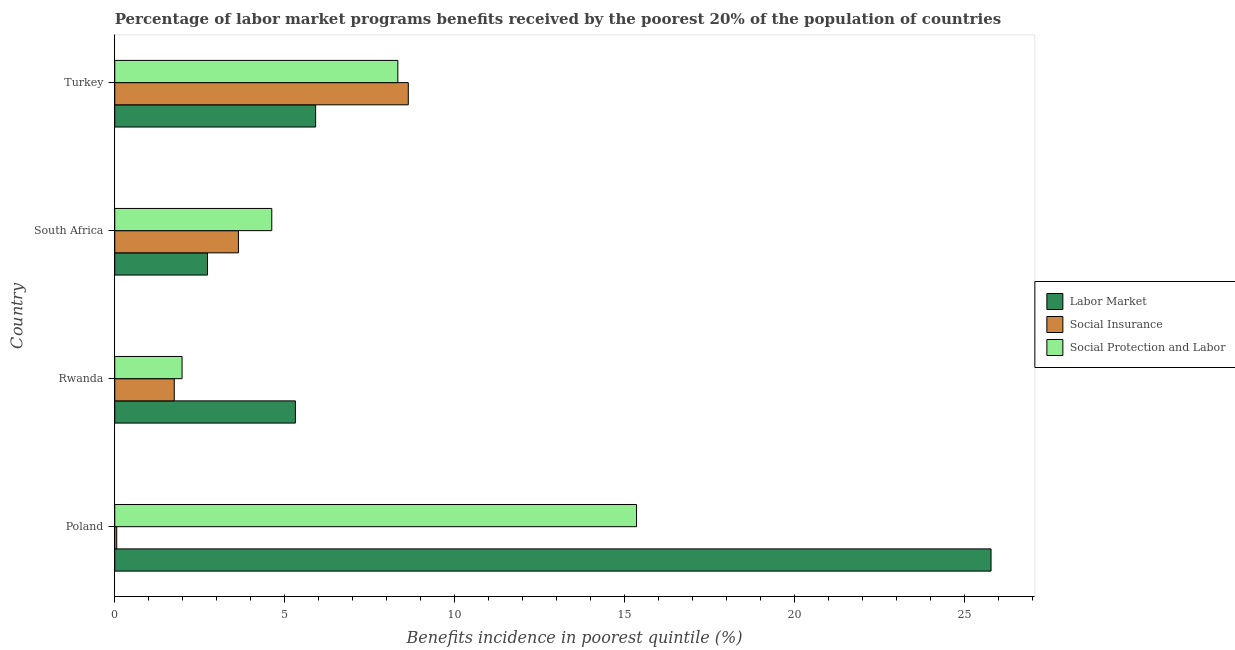Are the number of bars per tick equal to the number of legend labels?
Your answer should be very brief. Yes. Are the number of bars on each tick of the Y-axis equal?
Your answer should be compact. Yes. How many bars are there on the 3rd tick from the top?
Your answer should be compact. 3. How many bars are there on the 2nd tick from the bottom?
Ensure brevity in your answer.  3. What is the label of the 2nd group of bars from the top?
Keep it short and to the point. South Africa. What is the percentage of benefits received due to social insurance programs in South Africa?
Provide a short and direct response. 3.64. Across all countries, what is the maximum percentage of benefits received due to social insurance programs?
Your answer should be very brief. 8.64. Across all countries, what is the minimum percentage of benefits received due to social insurance programs?
Your response must be concise. 0.06. In which country was the percentage of benefits received due to labor market programs minimum?
Keep it short and to the point. South Africa. What is the total percentage of benefits received due to social insurance programs in the graph?
Your response must be concise. 14.09. What is the difference between the percentage of benefits received due to social protection programs in South Africa and that in Turkey?
Keep it short and to the point. -3.71. What is the difference between the percentage of benefits received due to social insurance programs in Turkey and the percentage of benefits received due to social protection programs in Rwanda?
Ensure brevity in your answer.  6.66. What is the average percentage of benefits received due to labor market programs per country?
Keep it short and to the point. 9.94. What is the difference between the percentage of benefits received due to labor market programs and percentage of benefits received due to social insurance programs in Rwanda?
Ensure brevity in your answer.  3.56. In how many countries, is the percentage of benefits received due to social protection programs greater than 17 %?
Your answer should be very brief. 0. What is the ratio of the percentage of benefits received due to labor market programs in Poland to that in Turkey?
Ensure brevity in your answer.  4.36. Is the difference between the percentage of benefits received due to social protection programs in Poland and Rwanda greater than the difference between the percentage of benefits received due to social insurance programs in Poland and Rwanda?
Offer a very short reply. Yes. What is the difference between the highest and the second highest percentage of benefits received due to labor market programs?
Ensure brevity in your answer.  19.88. What is the difference between the highest and the lowest percentage of benefits received due to social insurance programs?
Your answer should be very brief. 8.58. In how many countries, is the percentage of benefits received due to social insurance programs greater than the average percentage of benefits received due to social insurance programs taken over all countries?
Your response must be concise. 2. Is the sum of the percentage of benefits received due to social protection programs in Rwanda and South Africa greater than the maximum percentage of benefits received due to labor market programs across all countries?
Offer a very short reply. No. What does the 1st bar from the top in Poland represents?
Keep it short and to the point. Social Protection and Labor. What does the 2nd bar from the bottom in South Africa represents?
Offer a very short reply. Social Insurance. Is it the case that in every country, the sum of the percentage of benefits received due to labor market programs and percentage of benefits received due to social insurance programs is greater than the percentage of benefits received due to social protection programs?
Your answer should be very brief. Yes. How many bars are there?
Keep it short and to the point. 12. Are all the bars in the graph horizontal?
Your answer should be compact. Yes. How many countries are there in the graph?
Offer a terse response. 4. What is the difference between two consecutive major ticks on the X-axis?
Offer a very short reply. 5. Where does the legend appear in the graph?
Offer a very short reply. Center right. What is the title of the graph?
Offer a terse response. Percentage of labor market programs benefits received by the poorest 20% of the population of countries. Does "Food" appear as one of the legend labels in the graph?
Give a very brief answer. No. What is the label or title of the X-axis?
Offer a terse response. Benefits incidence in poorest quintile (%). What is the Benefits incidence in poorest quintile (%) in Labor Market in Poland?
Your response must be concise. 25.79. What is the Benefits incidence in poorest quintile (%) in Social Insurance in Poland?
Keep it short and to the point. 0.06. What is the Benefits incidence in poorest quintile (%) of Social Protection and Labor in Poland?
Keep it short and to the point. 15.36. What is the Benefits incidence in poorest quintile (%) of Labor Market in Rwanda?
Keep it short and to the point. 5.32. What is the Benefits incidence in poorest quintile (%) of Social Insurance in Rwanda?
Make the answer very short. 1.75. What is the Benefits incidence in poorest quintile (%) of Social Protection and Labor in Rwanda?
Your answer should be very brief. 1.98. What is the Benefits incidence in poorest quintile (%) of Labor Market in South Africa?
Offer a terse response. 2.73. What is the Benefits incidence in poorest quintile (%) of Social Insurance in South Africa?
Ensure brevity in your answer.  3.64. What is the Benefits incidence in poorest quintile (%) of Social Protection and Labor in South Africa?
Your answer should be very brief. 4.62. What is the Benefits incidence in poorest quintile (%) of Labor Market in Turkey?
Give a very brief answer. 5.91. What is the Benefits incidence in poorest quintile (%) of Social Insurance in Turkey?
Offer a very short reply. 8.64. What is the Benefits incidence in poorest quintile (%) of Social Protection and Labor in Turkey?
Keep it short and to the point. 8.33. Across all countries, what is the maximum Benefits incidence in poorest quintile (%) of Labor Market?
Keep it short and to the point. 25.79. Across all countries, what is the maximum Benefits incidence in poorest quintile (%) of Social Insurance?
Your answer should be compact. 8.64. Across all countries, what is the maximum Benefits incidence in poorest quintile (%) in Social Protection and Labor?
Your answer should be very brief. 15.36. Across all countries, what is the minimum Benefits incidence in poorest quintile (%) in Labor Market?
Keep it short and to the point. 2.73. Across all countries, what is the minimum Benefits incidence in poorest quintile (%) of Social Insurance?
Make the answer very short. 0.06. Across all countries, what is the minimum Benefits incidence in poorest quintile (%) in Social Protection and Labor?
Provide a short and direct response. 1.98. What is the total Benefits incidence in poorest quintile (%) of Labor Market in the graph?
Give a very brief answer. 39.75. What is the total Benefits incidence in poorest quintile (%) in Social Insurance in the graph?
Offer a terse response. 14.09. What is the total Benefits incidence in poorest quintile (%) in Social Protection and Labor in the graph?
Offer a terse response. 30.29. What is the difference between the Benefits incidence in poorest quintile (%) of Labor Market in Poland and that in Rwanda?
Make the answer very short. 20.47. What is the difference between the Benefits incidence in poorest quintile (%) of Social Insurance in Poland and that in Rwanda?
Give a very brief answer. -1.69. What is the difference between the Benefits incidence in poorest quintile (%) in Social Protection and Labor in Poland and that in Rwanda?
Ensure brevity in your answer.  13.38. What is the difference between the Benefits incidence in poorest quintile (%) in Labor Market in Poland and that in South Africa?
Your response must be concise. 23.06. What is the difference between the Benefits incidence in poorest quintile (%) in Social Insurance in Poland and that in South Africa?
Ensure brevity in your answer.  -3.58. What is the difference between the Benefits incidence in poorest quintile (%) of Social Protection and Labor in Poland and that in South Africa?
Offer a very short reply. 10.73. What is the difference between the Benefits incidence in poorest quintile (%) in Labor Market in Poland and that in Turkey?
Your answer should be very brief. 19.88. What is the difference between the Benefits incidence in poorest quintile (%) in Social Insurance in Poland and that in Turkey?
Your answer should be compact. -8.58. What is the difference between the Benefits incidence in poorest quintile (%) of Social Protection and Labor in Poland and that in Turkey?
Your response must be concise. 7.02. What is the difference between the Benefits incidence in poorest quintile (%) of Labor Market in Rwanda and that in South Africa?
Provide a succinct answer. 2.59. What is the difference between the Benefits incidence in poorest quintile (%) in Social Insurance in Rwanda and that in South Africa?
Provide a succinct answer. -1.89. What is the difference between the Benefits incidence in poorest quintile (%) of Social Protection and Labor in Rwanda and that in South Africa?
Offer a very short reply. -2.64. What is the difference between the Benefits incidence in poorest quintile (%) in Labor Market in Rwanda and that in Turkey?
Keep it short and to the point. -0.6. What is the difference between the Benefits incidence in poorest quintile (%) in Social Insurance in Rwanda and that in Turkey?
Your response must be concise. -6.89. What is the difference between the Benefits incidence in poorest quintile (%) in Social Protection and Labor in Rwanda and that in Turkey?
Make the answer very short. -6.35. What is the difference between the Benefits incidence in poorest quintile (%) of Labor Market in South Africa and that in Turkey?
Provide a short and direct response. -3.18. What is the difference between the Benefits incidence in poorest quintile (%) in Social Insurance in South Africa and that in Turkey?
Keep it short and to the point. -5. What is the difference between the Benefits incidence in poorest quintile (%) of Social Protection and Labor in South Africa and that in Turkey?
Ensure brevity in your answer.  -3.71. What is the difference between the Benefits incidence in poorest quintile (%) of Labor Market in Poland and the Benefits incidence in poorest quintile (%) of Social Insurance in Rwanda?
Offer a very short reply. 24.04. What is the difference between the Benefits incidence in poorest quintile (%) of Labor Market in Poland and the Benefits incidence in poorest quintile (%) of Social Protection and Labor in Rwanda?
Give a very brief answer. 23.81. What is the difference between the Benefits incidence in poorest quintile (%) in Social Insurance in Poland and the Benefits incidence in poorest quintile (%) in Social Protection and Labor in Rwanda?
Your answer should be very brief. -1.92. What is the difference between the Benefits incidence in poorest quintile (%) in Labor Market in Poland and the Benefits incidence in poorest quintile (%) in Social Insurance in South Africa?
Provide a short and direct response. 22.15. What is the difference between the Benefits incidence in poorest quintile (%) of Labor Market in Poland and the Benefits incidence in poorest quintile (%) of Social Protection and Labor in South Africa?
Give a very brief answer. 21.17. What is the difference between the Benefits incidence in poorest quintile (%) of Social Insurance in Poland and the Benefits incidence in poorest quintile (%) of Social Protection and Labor in South Africa?
Provide a short and direct response. -4.56. What is the difference between the Benefits incidence in poorest quintile (%) of Labor Market in Poland and the Benefits incidence in poorest quintile (%) of Social Insurance in Turkey?
Provide a succinct answer. 17.15. What is the difference between the Benefits incidence in poorest quintile (%) in Labor Market in Poland and the Benefits incidence in poorest quintile (%) in Social Protection and Labor in Turkey?
Your answer should be compact. 17.46. What is the difference between the Benefits incidence in poorest quintile (%) in Social Insurance in Poland and the Benefits incidence in poorest quintile (%) in Social Protection and Labor in Turkey?
Your answer should be compact. -8.27. What is the difference between the Benefits incidence in poorest quintile (%) in Labor Market in Rwanda and the Benefits incidence in poorest quintile (%) in Social Insurance in South Africa?
Your answer should be very brief. 1.68. What is the difference between the Benefits incidence in poorest quintile (%) in Labor Market in Rwanda and the Benefits incidence in poorest quintile (%) in Social Protection and Labor in South Africa?
Your response must be concise. 0.69. What is the difference between the Benefits incidence in poorest quintile (%) in Social Insurance in Rwanda and the Benefits incidence in poorest quintile (%) in Social Protection and Labor in South Africa?
Your answer should be very brief. -2.87. What is the difference between the Benefits incidence in poorest quintile (%) in Labor Market in Rwanda and the Benefits incidence in poorest quintile (%) in Social Insurance in Turkey?
Your answer should be compact. -3.32. What is the difference between the Benefits incidence in poorest quintile (%) in Labor Market in Rwanda and the Benefits incidence in poorest quintile (%) in Social Protection and Labor in Turkey?
Provide a short and direct response. -3.02. What is the difference between the Benefits incidence in poorest quintile (%) of Social Insurance in Rwanda and the Benefits incidence in poorest quintile (%) of Social Protection and Labor in Turkey?
Make the answer very short. -6.58. What is the difference between the Benefits incidence in poorest quintile (%) of Labor Market in South Africa and the Benefits incidence in poorest quintile (%) of Social Insurance in Turkey?
Your answer should be compact. -5.91. What is the difference between the Benefits incidence in poorest quintile (%) in Labor Market in South Africa and the Benefits incidence in poorest quintile (%) in Social Protection and Labor in Turkey?
Keep it short and to the point. -5.6. What is the difference between the Benefits incidence in poorest quintile (%) of Social Insurance in South Africa and the Benefits incidence in poorest quintile (%) of Social Protection and Labor in Turkey?
Offer a very short reply. -4.69. What is the average Benefits incidence in poorest quintile (%) of Labor Market per country?
Make the answer very short. 9.94. What is the average Benefits incidence in poorest quintile (%) of Social Insurance per country?
Provide a succinct answer. 3.52. What is the average Benefits incidence in poorest quintile (%) in Social Protection and Labor per country?
Your response must be concise. 7.57. What is the difference between the Benefits incidence in poorest quintile (%) in Labor Market and Benefits incidence in poorest quintile (%) in Social Insurance in Poland?
Provide a succinct answer. 25.73. What is the difference between the Benefits incidence in poorest quintile (%) of Labor Market and Benefits incidence in poorest quintile (%) of Social Protection and Labor in Poland?
Provide a short and direct response. 10.43. What is the difference between the Benefits incidence in poorest quintile (%) of Social Insurance and Benefits incidence in poorest quintile (%) of Social Protection and Labor in Poland?
Ensure brevity in your answer.  -15.3. What is the difference between the Benefits incidence in poorest quintile (%) of Labor Market and Benefits incidence in poorest quintile (%) of Social Insurance in Rwanda?
Your answer should be compact. 3.56. What is the difference between the Benefits incidence in poorest quintile (%) in Labor Market and Benefits incidence in poorest quintile (%) in Social Protection and Labor in Rwanda?
Offer a terse response. 3.34. What is the difference between the Benefits incidence in poorest quintile (%) of Social Insurance and Benefits incidence in poorest quintile (%) of Social Protection and Labor in Rwanda?
Ensure brevity in your answer.  -0.23. What is the difference between the Benefits incidence in poorest quintile (%) of Labor Market and Benefits incidence in poorest quintile (%) of Social Insurance in South Africa?
Your answer should be very brief. -0.91. What is the difference between the Benefits incidence in poorest quintile (%) in Labor Market and Benefits incidence in poorest quintile (%) in Social Protection and Labor in South Africa?
Your answer should be very brief. -1.89. What is the difference between the Benefits incidence in poorest quintile (%) in Social Insurance and Benefits incidence in poorest quintile (%) in Social Protection and Labor in South Africa?
Ensure brevity in your answer.  -0.98. What is the difference between the Benefits incidence in poorest quintile (%) of Labor Market and Benefits incidence in poorest quintile (%) of Social Insurance in Turkey?
Keep it short and to the point. -2.73. What is the difference between the Benefits incidence in poorest quintile (%) in Labor Market and Benefits incidence in poorest quintile (%) in Social Protection and Labor in Turkey?
Ensure brevity in your answer.  -2.42. What is the difference between the Benefits incidence in poorest quintile (%) of Social Insurance and Benefits incidence in poorest quintile (%) of Social Protection and Labor in Turkey?
Offer a terse response. 0.31. What is the ratio of the Benefits incidence in poorest quintile (%) in Labor Market in Poland to that in Rwanda?
Your answer should be very brief. 4.85. What is the ratio of the Benefits incidence in poorest quintile (%) of Social Insurance in Poland to that in Rwanda?
Offer a terse response. 0.03. What is the ratio of the Benefits incidence in poorest quintile (%) of Social Protection and Labor in Poland to that in Rwanda?
Provide a short and direct response. 7.75. What is the ratio of the Benefits incidence in poorest quintile (%) of Labor Market in Poland to that in South Africa?
Offer a terse response. 9.45. What is the ratio of the Benefits incidence in poorest quintile (%) of Social Insurance in Poland to that in South Africa?
Keep it short and to the point. 0.02. What is the ratio of the Benefits incidence in poorest quintile (%) in Social Protection and Labor in Poland to that in South Africa?
Your answer should be compact. 3.32. What is the ratio of the Benefits incidence in poorest quintile (%) in Labor Market in Poland to that in Turkey?
Your response must be concise. 4.36. What is the ratio of the Benefits incidence in poorest quintile (%) of Social Insurance in Poland to that in Turkey?
Your answer should be compact. 0.01. What is the ratio of the Benefits incidence in poorest quintile (%) in Social Protection and Labor in Poland to that in Turkey?
Keep it short and to the point. 1.84. What is the ratio of the Benefits incidence in poorest quintile (%) of Labor Market in Rwanda to that in South Africa?
Your answer should be compact. 1.95. What is the ratio of the Benefits incidence in poorest quintile (%) in Social Insurance in Rwanda to that in South Africa?
Provide a succinct answer. 0.48. What is the ratio of the Benefits incidence in poorest quintile (%) of Social Protection and Labor in Rwanda to that in South Africa?
Give a very brief answer. 0.43. What is the ratio of the Benefits incidence in poorest quintile (%) in Labor Market in Rwanda to that in Turkey?
Give a very brief answer. 0.9. What is the ratio of the Benefits incidence in poorest quintile (%) of Social Insurance in Rwanda to that in Turkey?
Provide a short and direct response. 0.2. What is the ratio of the Benefits incidence in poorest quintile (%) in Social Protection and Labor in Rwanda to that in Turkey?
Provide a succinct answer. 0.24. What is the ratio of the Benefits incidence in poorest quintile (%) in Labor Market in South Africa to that in Turkey?
Provide a short and direct response. 0.46. What is the ratio of the Benefits incidence in poorest quintile (%) in Social Insurance in South Africa to that in Turkey?
Offer a terse response. 0.42. What is the ratio of the Benefits incidence in poorest quintile (%) of Social Protection and Labor in South Africa to that in Turkey?
Offer a terse response. 0.55. What is the difference between the highest and the second highest Benefits incidence in poorest quintile (%) in Labor Market?
Your answer should be very brief. 19.88. What is the difference between the highest and the second highest Benefits incidence in poorest quintile (%) of Social Insurance?
Your response must be concise. 5. What is the difference between the highest and the second highest Benefits incidence in poorest quintile (%) in Social Protection and Labor?
Offer a very short reply. 7.02. What is the difference between the highest and the lowest Benefits incidence in poorest quintile (%) of Labor Market?
Your answer should be compact. 23.06. What is the difference between the highest and the lowest Benefits incidence in poorest quintile (%) of Social Insurance?
Offer a terse response. 8.58. What is the difference between the highest and the lowest Benefits incidence in poorest quintile (%) of Social Protection and Labor?
Give a very brief answer. 13.38. 